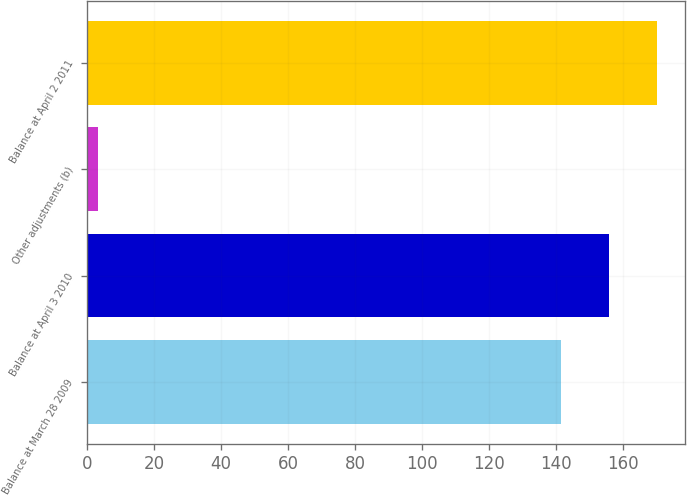Convert chart to OTSL. <chart><loc_0><loc_0><loc_500><loc_500><bar_chart><fcel>Balance at March 28 2009<fcel>Balance at April 3 2010<fcel>Other adjustments (b)<fcel>Balance at April 2 2011<nl><fcel>141.5<fcel>155.75<fcel>3.3<fcel>170<nl></chart> 